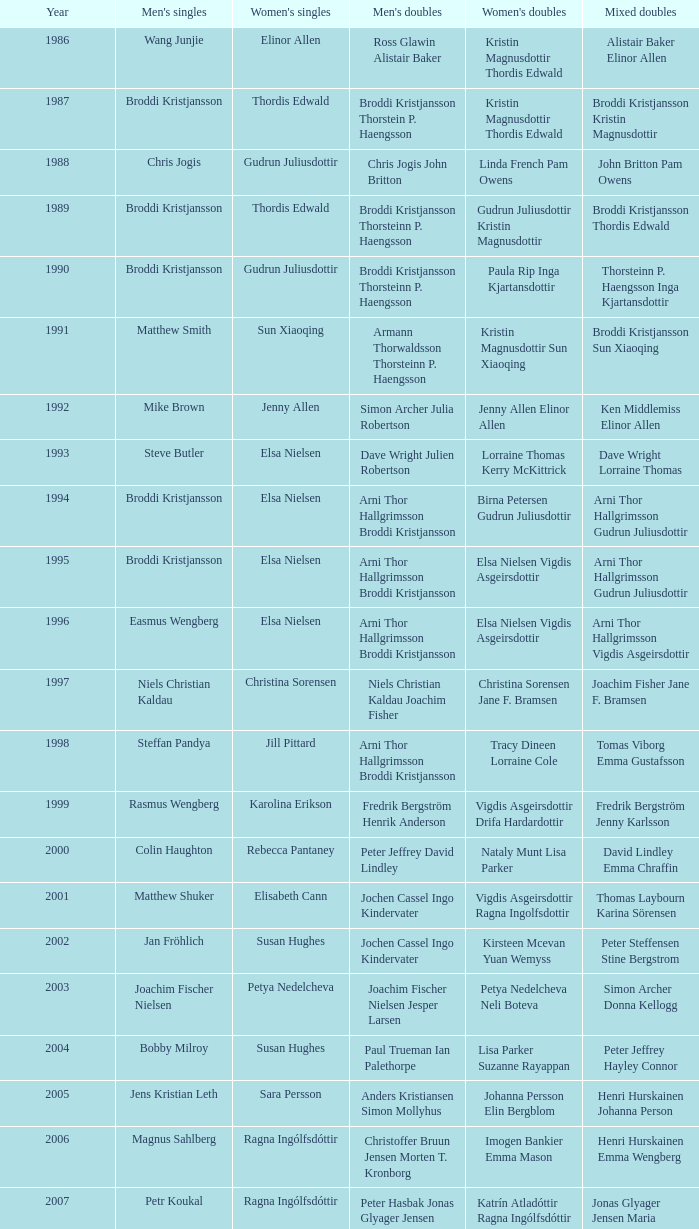Which mixed doubles happened later than 2011? Chou Tien-chen Chiang Mei-hui. 